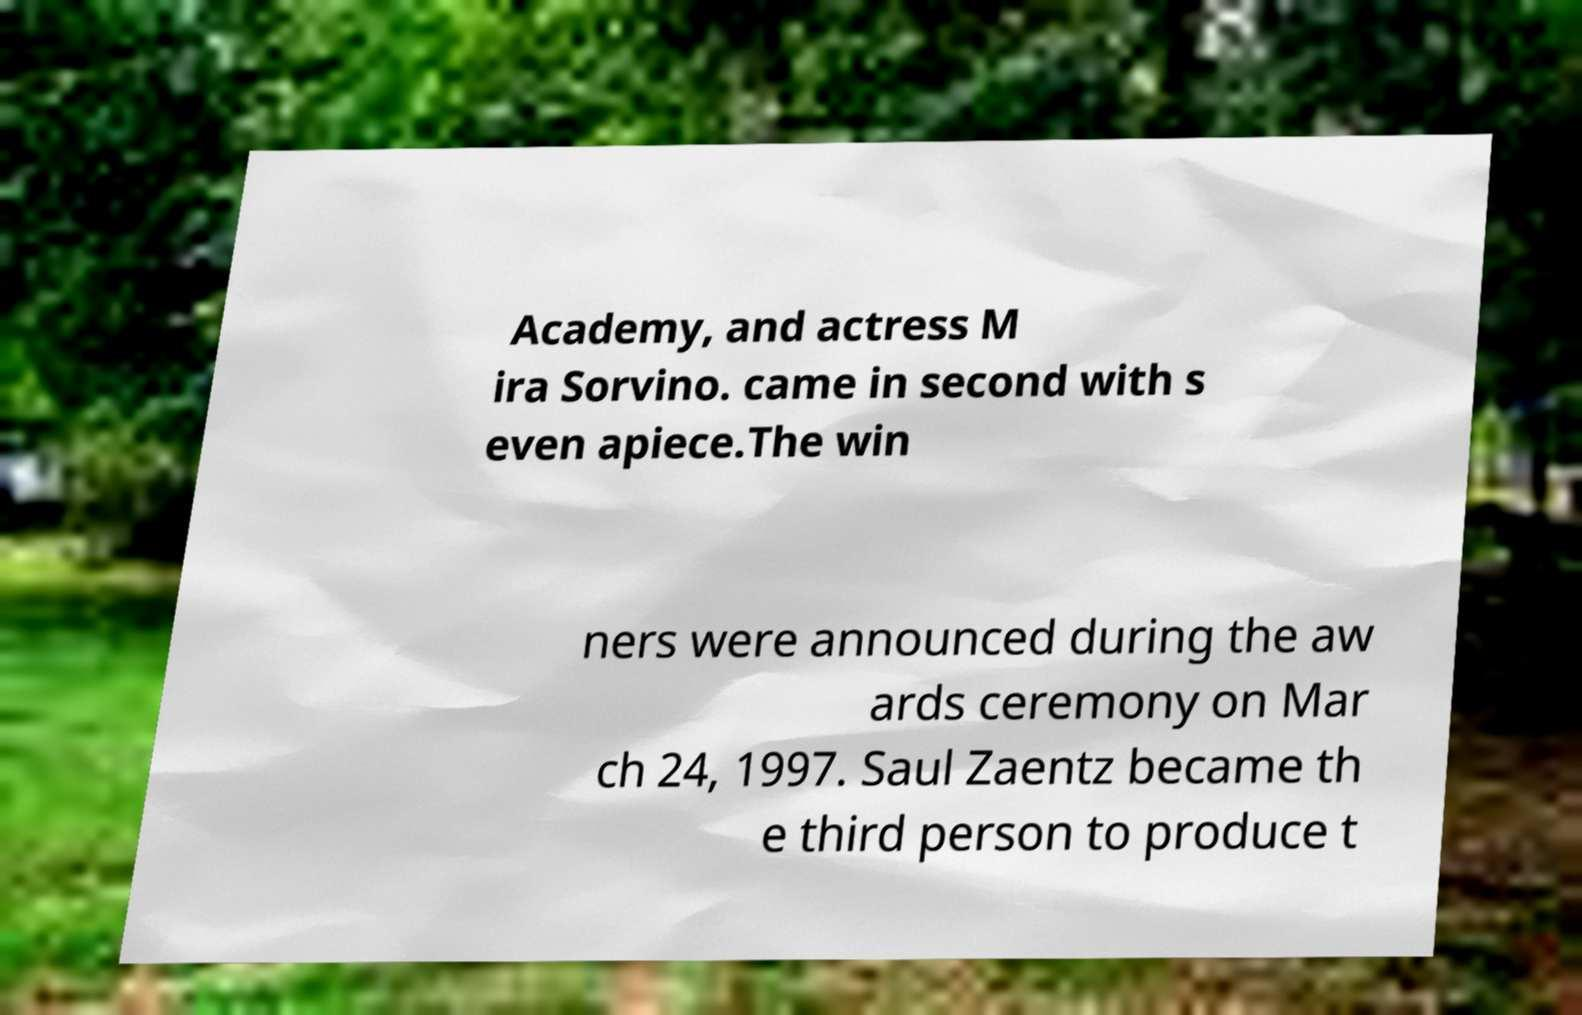Can you read and provide the text displayed in the image?This photo seems to have some interesting text. Can you extract and type it out for me? Academy, and actress M ira Sorvino. came in second with s even apiece.The win ners were announced during the aw ards ceremony on Mar ch 24, 1997. Saul Zaentz became th e third person to produce t 